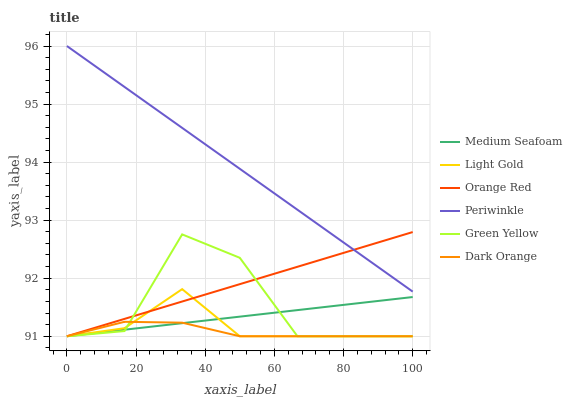Does Orange Red have the minimum area under the curve?
Answer yes or no. No. Does Orange Red have the maximum area under the curve?
Answer yes or no. No. Is Orange Red the smoothest?
Answer yes or no. No. Is Orange Red the roughest?
Answer yes or no. No. Does Periwinkle have the lowest value?
Answer yes or no. No. Does Orange Red have the highest value?
Answer yes or no. No. Is Light Gold less than Periwinkle?
Answer yes or no. Yes. Is Periwinkle greater than Green Yellow?
Answer yes or no. Yes. Does Light Gold intersect Periwinkle?
Answer yes or no. No. 